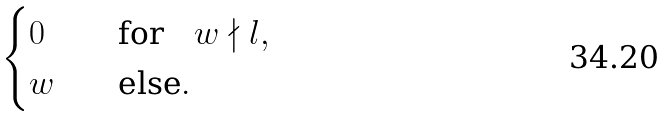<formula> <loc_0><loc_0><loc_500><loc_500>\begin{cases} 0 & \quad \text {for} \quad w \nmid l , \\ w & \quad \text {else} . \end{cases}</formula> 